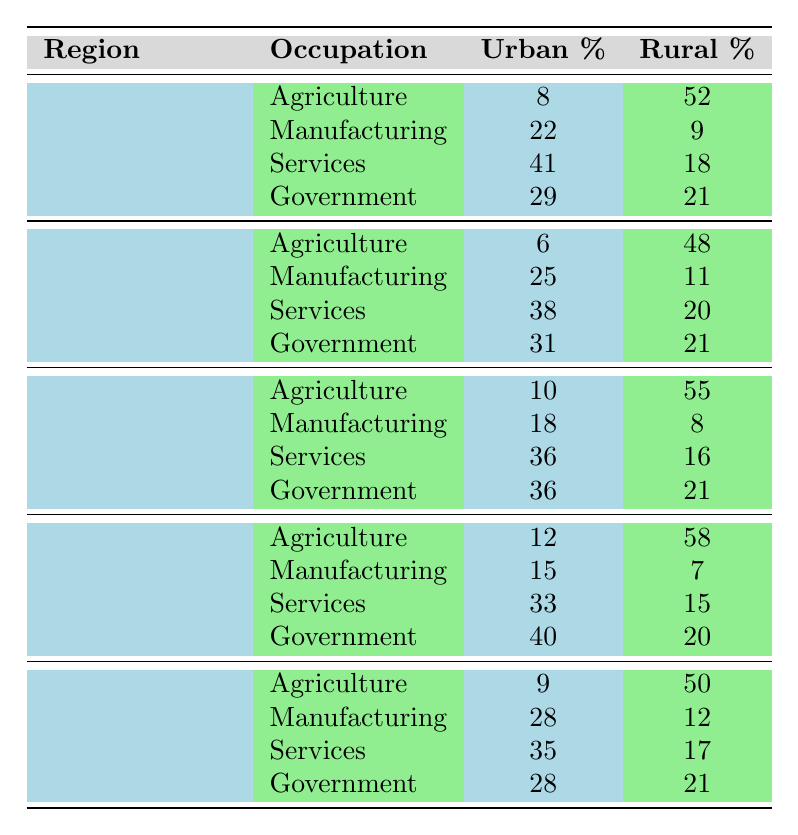What is the urban percentage of government workers in the Erbil Governorate? The table indicates that the urban percentage of government workers in Erbil is listed as 29%.
Answer: 29% Which occupation has the highest percentage in urban areas in the Duhok Governorate? Looking at the urban percentages for Duhok, the highest percentage is in Services, which is 36%.
Answer: Services What is the rural percentage of services workers in the Halabja Governorate? According to the table, the rural percentage for services workers in Halabja is 15%.
Answer: 15% In which governorate is the percentage of agriculture workers higher in rural areas than in urban areas? By comparing the percentages, Halabja has a rural percentage of 58% for agriculture, which is significantly higher than the urban percentage of 12%.
Answer: Halabja What is the total urban percentage of manufacturing workers across all governorates combined? Adding the urban percentages for manufacturing: Erbil (22) + Sulaymaniyah (25) + Duhok (18) + Halabja (15) + Kirkuk (28) gives a total of 108%.
Answer: 108% Is the rural percentage of services workers higher in Kirkuk than in Erbil? From the data, Kirkuk has a rural percentage of 17% for services, while Erbil has 18%. Thus, Erbil has a higher percentage.
Answer: No What is the average urban percentage for government workers across all governorates? The urban percentages for government workers are: Erbil (29), Sulaymaniyah (31), Duhok (36), Halabja (40), and Kirkuk (28). To find the average, we sum these percentages (29 + 31 + 36 + 40 + 28 = 164) and divide by 5, resulting in an average of 32.8%.
Answer: 32.8% Which governorate has the lowest urban percentage for agriculture workers? In the table, Sulaymaniyah has the lowest urban percentage for agriculture at 6%.
Answer: Sulaymaniyah What is the difference between the urban and rural percentages of manufacturing workers in Sulaymaniyah? The urban percentage for manufacturing in Sulaymaniyah is 25%, and the rural percentage is 11%. The difference is calculated as 25 - 11 = 14%.
Answer: 14% For which occupation does Halabja show the largest difference between urban and rural percentages? Analyzing the data for Halabja, Government shows a difference of 20% (40 urban - 20 rural). No other occupation has a larger difference.
Answer: Government 